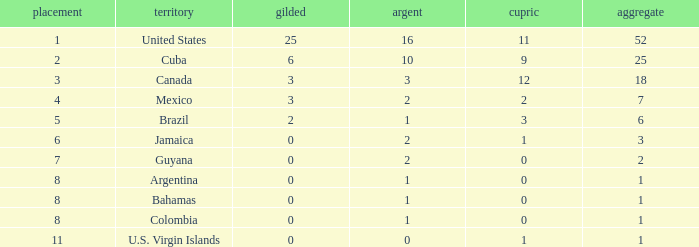What is the fewest number of silver medals a nation who ranked below 8 received? 0.0. 